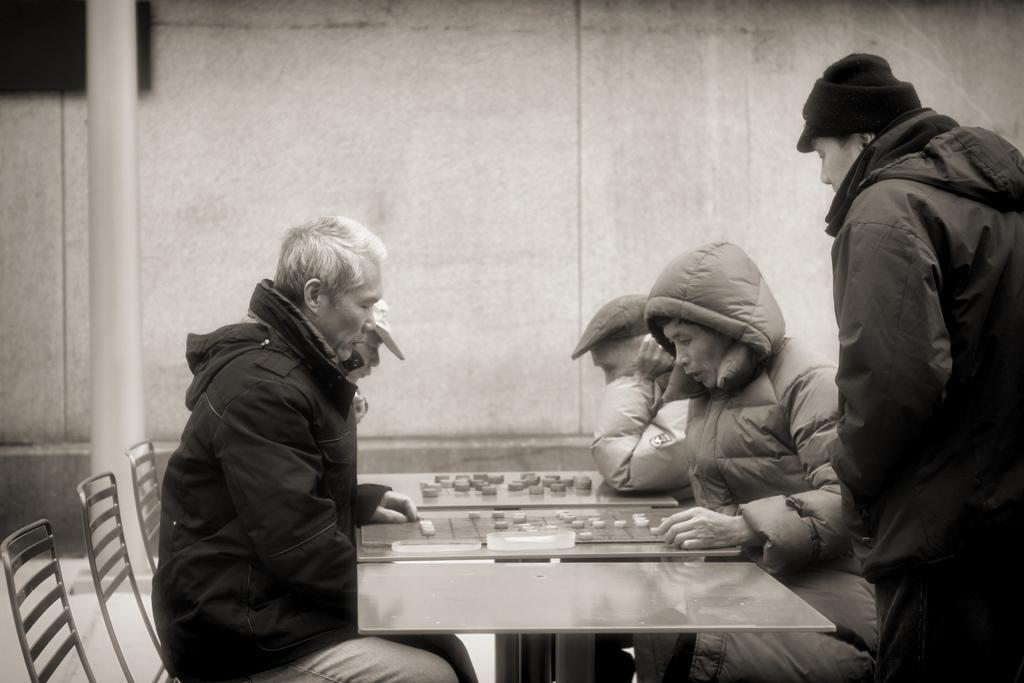What are the people in the image doing? The people in the image are sitting on chairs. What is present on the table in the image? There is a table in the image, and a game is being played on it. Is there anyone standing near the table? Yes, one person is standing near the table. What type of oatmeal is being served at the feast in the image? There is no feast or oatmeal present in the image; it features people sitting on chairs and playing a game on a table. What type of exchange is taking place between the people in the image? There is no exchange taking place between the place between the people in the image; they are sitting and playing a game. 